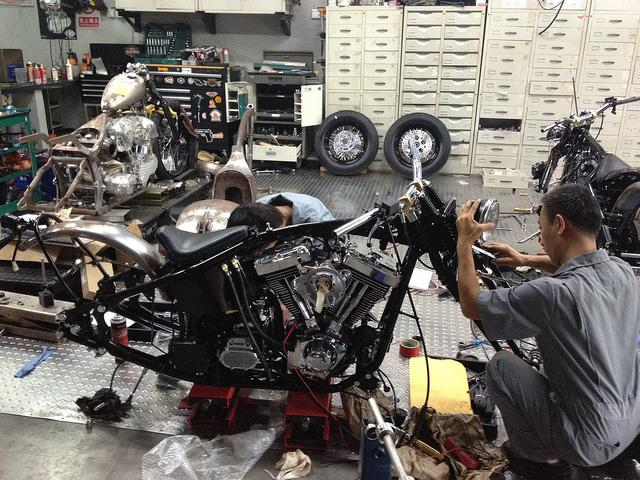What are the cabinets in the background called? Please explain your reasoning. safes. The person is working in a mechanics shop based on their equipment, uniform and the act they are seen doing. this type of setting would include many containers for housing their tools. 